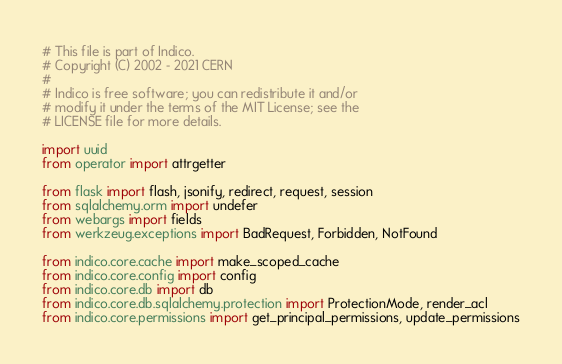<code> <loc_0><loc_0><loc_500><loc_500><_Python_># This file is part of Indico.
# Copyright (C) 2002 - 2021 CERN
#
# Indico is free software; you can redistribute it and/or
# modify it under the terms of the MIT License; see the
# LICENSE file for more details.

import uuid
from operator import attrgetter

from flask import flash, jsonify, redirect, request, session
from sqlalchemy.orm import undefer
from webargs import fields
from werkzeug.exceptions import BadRequest, Forbidden, NotFound

from indico.core.cache import make_scoped_cache
from indico.core.config import config
from indico.core.db import db
from indico.core.db.sqlalchemy.protection import ProtectionMode, render_acl
from indico.core.permissions import get_principal_permissions, update_permissions</code> 